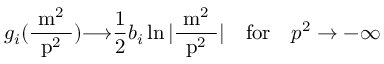Convert formula to latex. <formula><loc_0><loc_0><loc_500><loc_500>g _ { i } ( \frac { m ^ { 2 } } { p ^ { 2 } } ) { \longrightarrow } \frac { 1 } { 2 } b _ { i } \ln | \frac { m ^ { 2 } } { p ^ { 2 } } | \quad f o r \quad p ^ { 2 } \to - \infty</formula> 